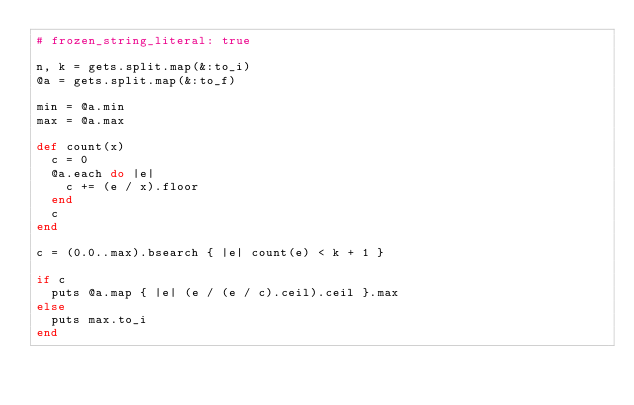Convert code to text. <code><loc_0><loc_0><loc_500><loc_500><_Ruby_># frozen_string_literal: true

n, k = gets.split.map(&:to_i)
@a = gets.split.map(&:to_f)

min = @a.min
max = @a.max

def count(x)
  c = 0
  @a.each do |e|
    c += (e / x).floor
  end
  c
end

c = (0.0..max).bsearch { |e| count(e) < k + 1 }

if c
  puts @a.map { |e| (e / (e / c).ceil).ceil }.max
else
  puts max.to_i
end
</code> 